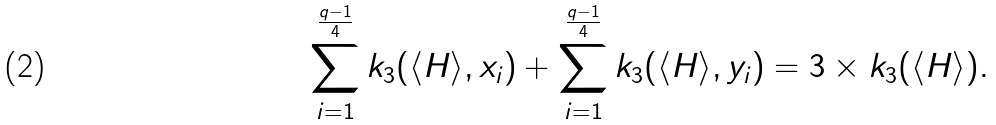Convert formula to latex. <formula><loc_0><loc_0><loc_500><loc_500>\sum _ { i = 1 } ^ { \frac { q - 1 } { 4 } } k _ { 3 } ( \langle H \rangle , x _ { i } ) + \sum _ { i = 1 } ^ { \frac { q - 1 } { 4 } } k _ { 3 } ( \langle H \rangle , y _ { i } ) = 3 \times k _ { 3 } ( \langle H \rangle ) .</formula> 